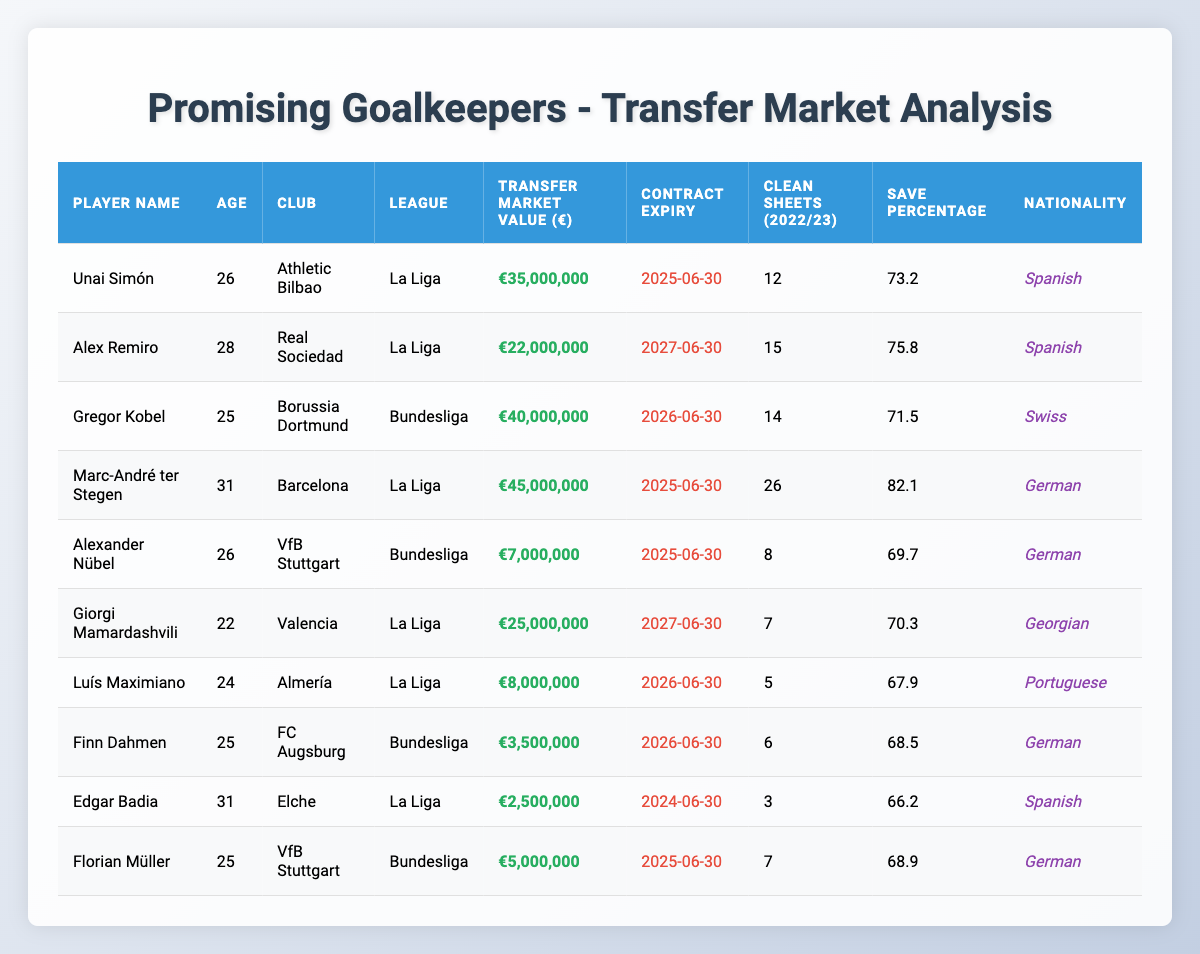What is the highest transfer market value among the goalkeepers listed? The highest transfer market value is €45,000,000, which belongs to Marc-André ter Stegen of Barcelona.
Answer: €45,000,000 Which goalkeeper has the most clean sheets in the 2022/23 season? Marc-André ter Stegen has the most clean sheets with 26.
Answer: 26 How many goalkeepers have a save percentage above 70%? Three goalkeepers have a save percentage above 70%: Alex Remiro (75.8%), Marc-André ter Stegen (82.1%), and Unai Simón (73.2%).
Answer: 3 What is the average transfer market value of the players from La Liga? The total transfer market value of La Liga goalkeepers is €113,000,000 (35 + 22 + 45 + 25 + 8 + 2) = 137,000,000, and there are 6 players, so the average is €137,000,000 / 6 = approximately €22,833,333.
Answer: €22,833,333 Which goalkeeper has the longest contract duration? Alex Remiro and Giorgi Mamardashvili both have contracts expiring on 2027-06-30, which gives them the longest duration before expiry.
Answer: Alex Remiro and Giorgi Mamardashvili Is there any goalkeeper from the Bundesliga with a market value below €10 million? Yes, Alexander Nübel and Finn Dahmen from the Bundesliga have market values below €10 million (€7,000,000 and €3,500,000 respectively).
Answer: Yes What is the combined number of clean sheets by La Liga goalkeepers? The combined number of clean sheets is 12 (Unai Simón) + 15 (Alex Remiro) + 26 (Marc-André ter Stegen) + 7 (Giorgi Mamardashvili) + 5 (Luís Maximiano) + 3 (Edgar Badia) = 68 clean sheets in total.
Answer: 68 Which goalkeeper from the Bundesliga has the highest save percentage? Gregor Kobel has the highest save percentage among Bundesliga goalkeepers at 71.5%.
Answer: Gregor Kobel If you exclude the oldest goalkeeper, what is the average age of the remaining goalkeepers? Excluding the oldest (Marc-André ter Stegen, who is 31), the remaining ages are 26, 28, 25, 26, 24, and 25, totaling 6 players. Their total age is 26 + 28 + 25 + 26 + 24 + 25 = 154. Therefore, the average age is 154 / 6 = approximately 25.67.
Answer: 25.67 What percentage of La Liga's listed goalkeepers are Spanish? Out of 6 La Liga goalkeepers, 4 are Spanish (Unai Simón, Alex Remiro, Edgar Badia, and Luís Maximiano). So, the percentage is (4/6) * 100 = approximately 66.67%.
Answer: 66.67% 